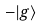Convert formula to latex. <formula><loc_0><loc_0><loc_500><loc_500>- | g \rangle</formula> 